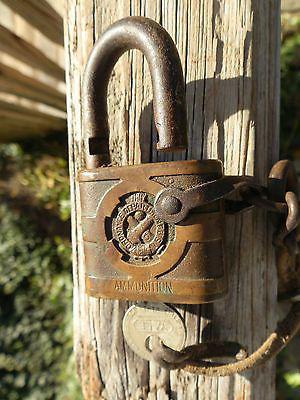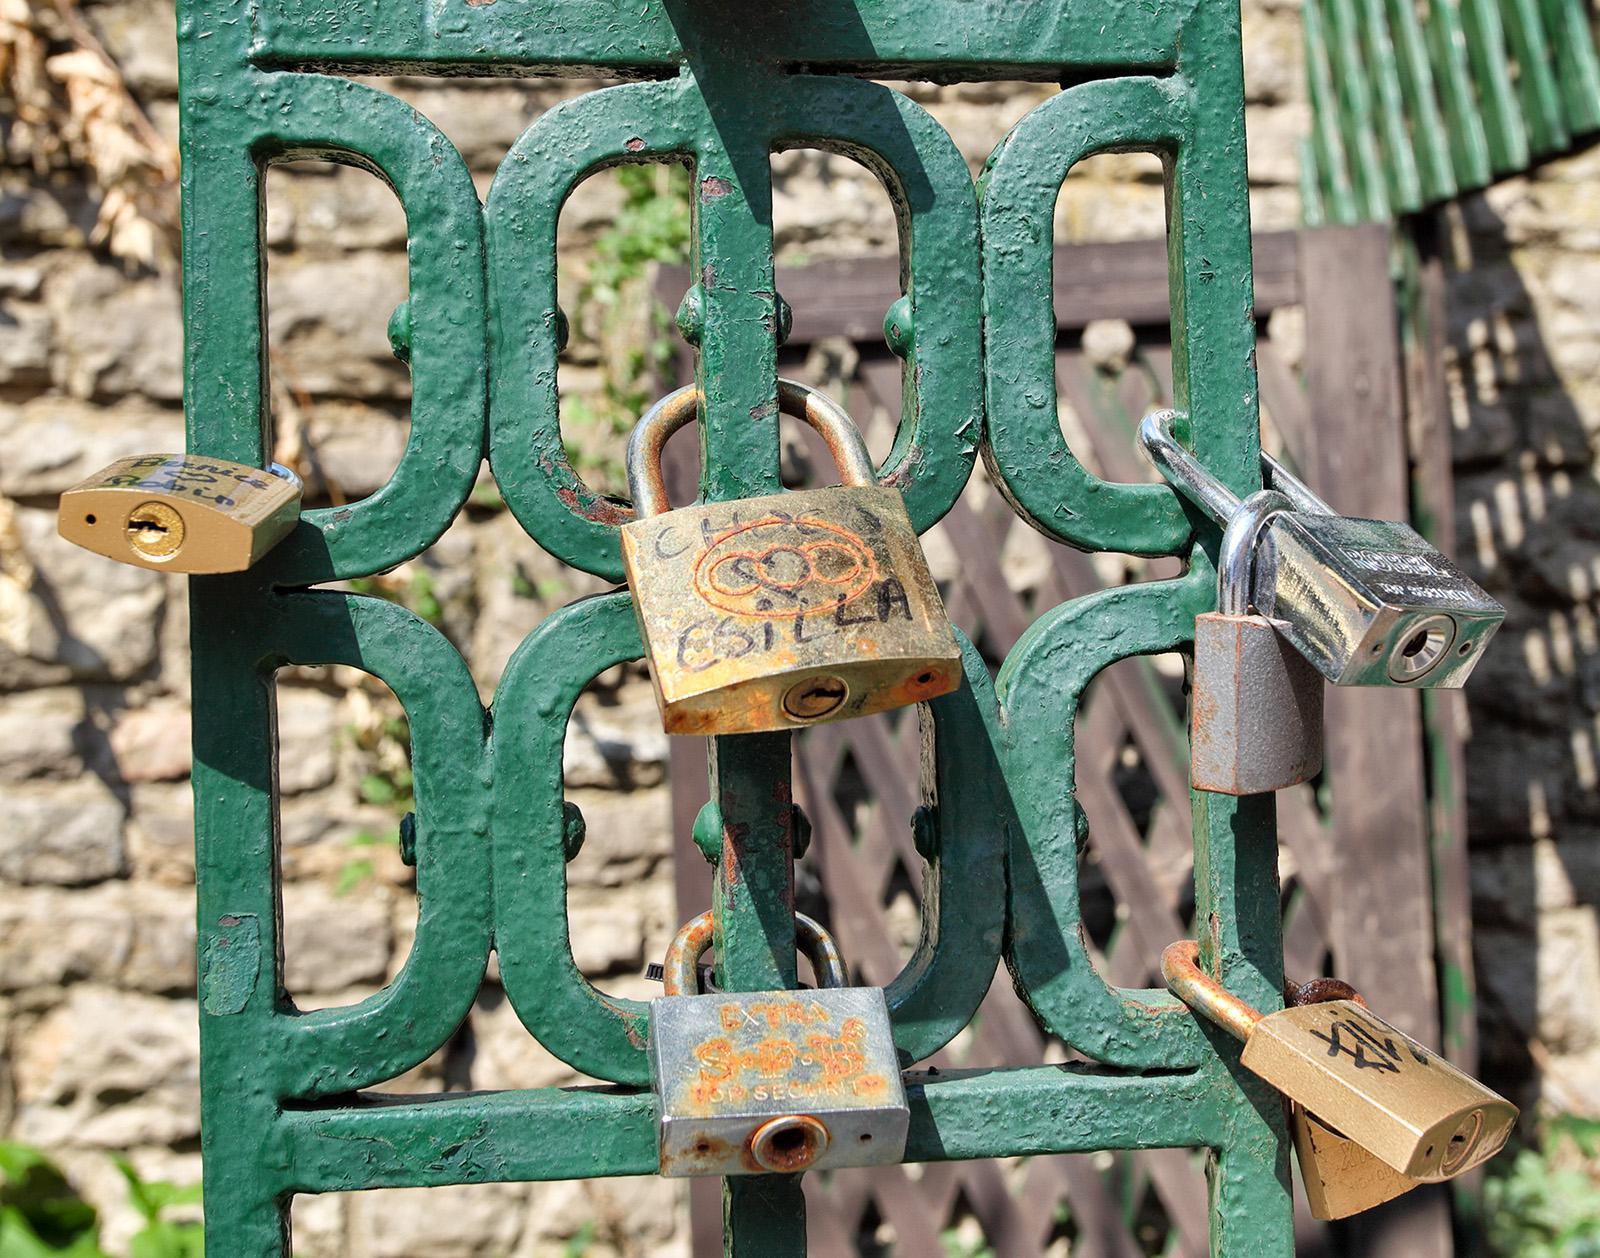The first image is the image on the left, the second image is the image on the right. Examine the images to the left and right. Is the description "Multiple squarish padlocks are attached to openings in something made of greenish metal." accurate? Answer yes or no. Yes. The first image is the image on the left, the second image is the image on the right. Analyze the images presented: Is the assertion "One image contains exactly one padlock." valid? Answer yes or no. Yes. 